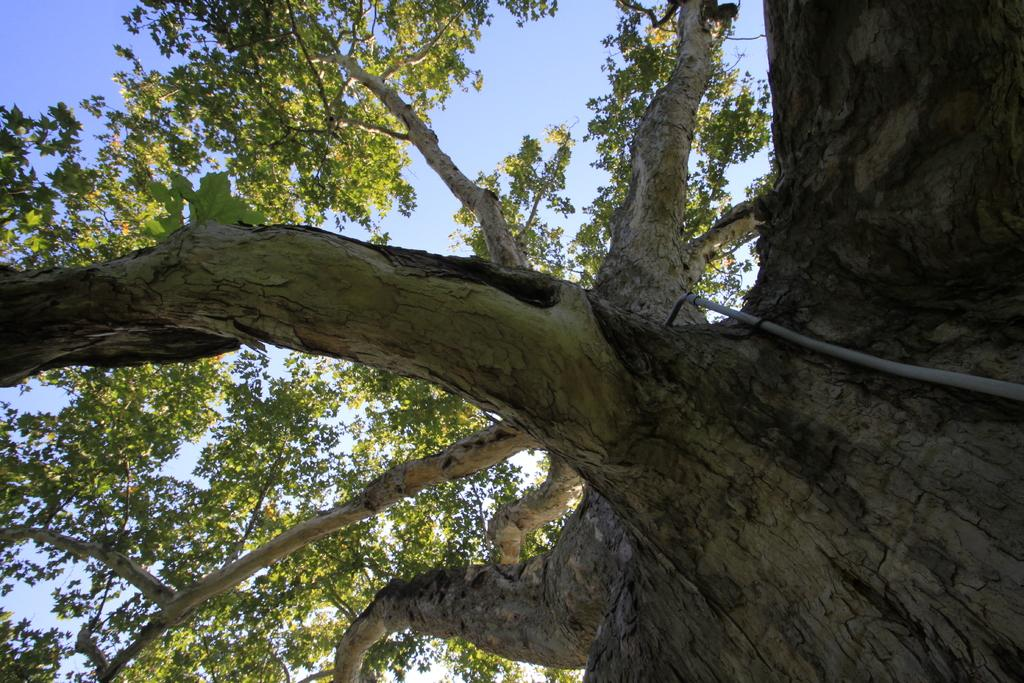What type of vegetation can be seen in the image? There are branches in the image. What is visible in the background of the image? The sky is visible in the background of the image. What type of list can be seen hanging from the branches in the image? There is no list present in the image; only branches and the sky are visible. 